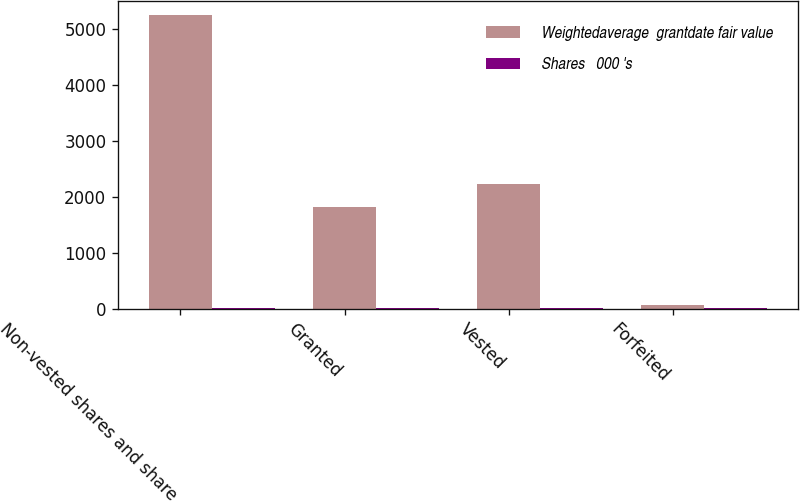<chart> <loc_0><loc_0><loc_500><loc_500><stacked_bar_chart><ecel><fcel>Non-vested shares and share<fcel>Granted<fcel>Vested<fcel>Forfeited<nl><fcel>Weightedaverage  grantdate fair value<fcel>5242<fcel>1815<fcel>2238<fcel>72<nl><fcel>Shares   000 's<fcel>17.91<fcel>21.49<fcel>14.35<fcel>21.11<nl></chart> 